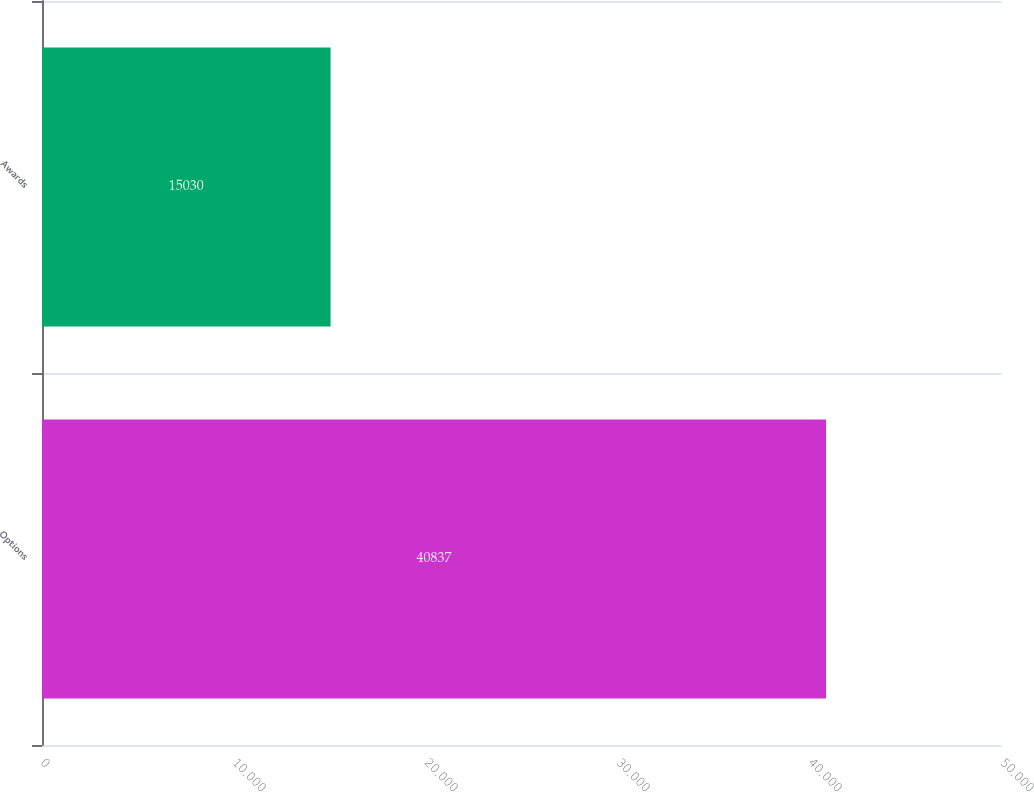Convert chart to OTSL. <chart><loc_0><loc_0><loc_500><loc_500><bar_chart><fcel>Options<fcel>Awards<nl><fcel>40837<fcel>15030<nl></chart> 